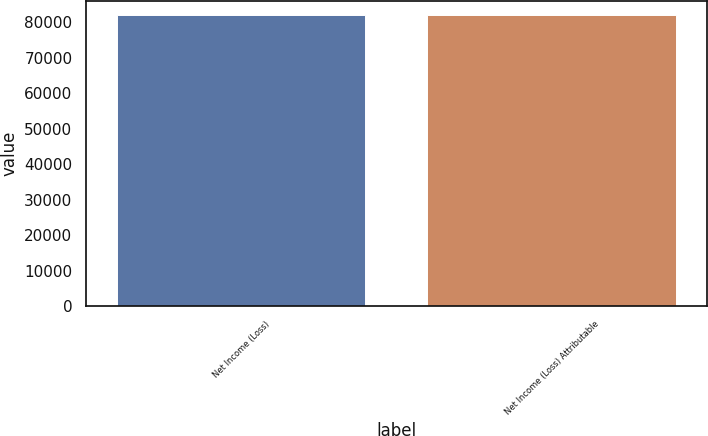Convert chart to OTSL. <chart><loc_0><loc_0><loc_500><loc_500><bar_chart><fcel>Net Income (Loss)<fcel>Net Income (Loss) Attributable<nl><fcel>82037<fcel>82037.1<nl></chart> 